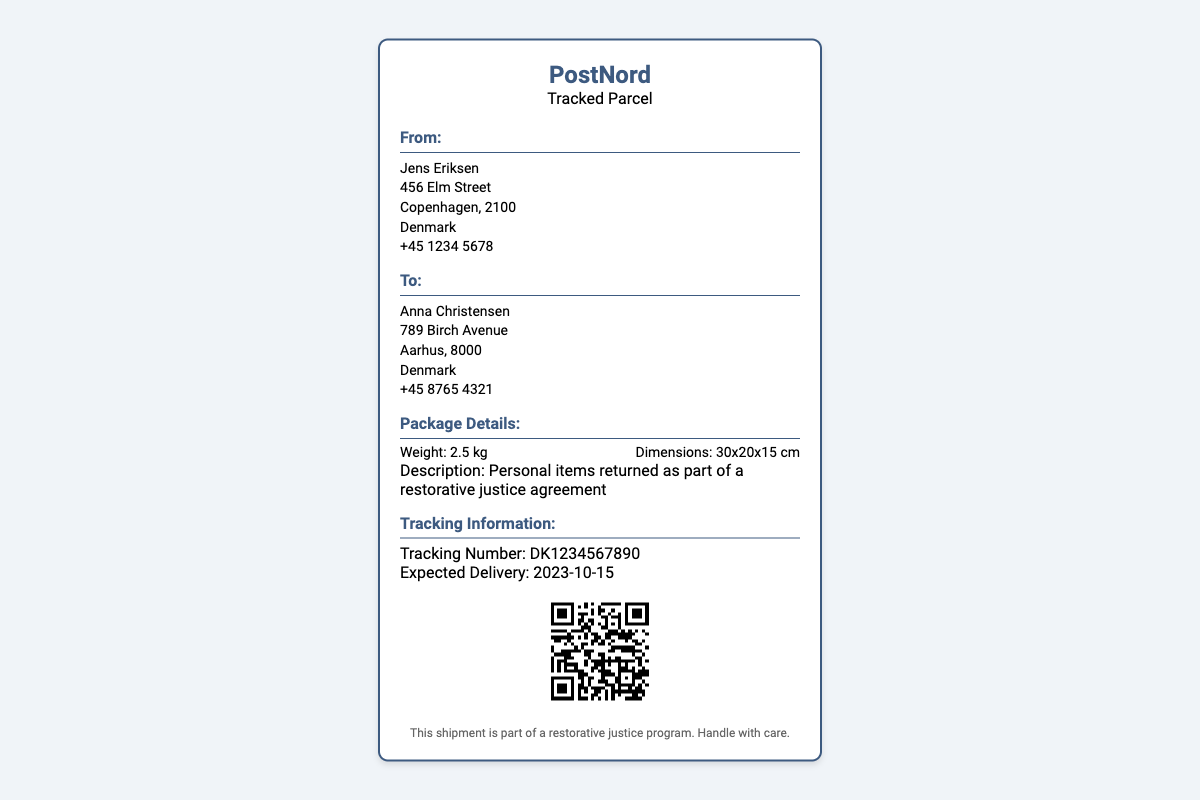What is the sender's name? The sender's name is mentioned in the "From" section of the shipping label.
Answer: Jens Eriksen What is the recipient's address? The recipient's address is found in the "To" section of the document.
Answer: 789 Birch Avenue, Aarhus, 8000, Denmark What is the tracking number? The tracking number is provided in the "Tracking Information" section.
Answer: DK1234567890 What is the weight of the package? The weight is listed in the "Package Details" section.
Answer: 2.5 kg What type of agreement is mentioned? This information can be found in the description within the "Package Details" section.
Answer: Restorative justice agreement When is the expected delivery date? The expected delivery date is given in the "Tracking Information" section.
Answer: 2023-10-15 How many items are being returned? The document doesn't specify the number of items but describes the contents generically.
Answer: Personal items What is indicated under the footer? The footer typically contains additional information about the shipment's nature.
Answer: This shipment is part of a restorative justice program. Handle with care What is the QR code used for? This relates to the tracking functionality of the shipment that can be accessed via the QR code.
Answer: Tracking information 